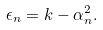<formula> <loc_0><loc_0><loc_500><loc_500>\epsilon _ { n } = k - \alpha _ { n } ^ { 2 } .</formula> 